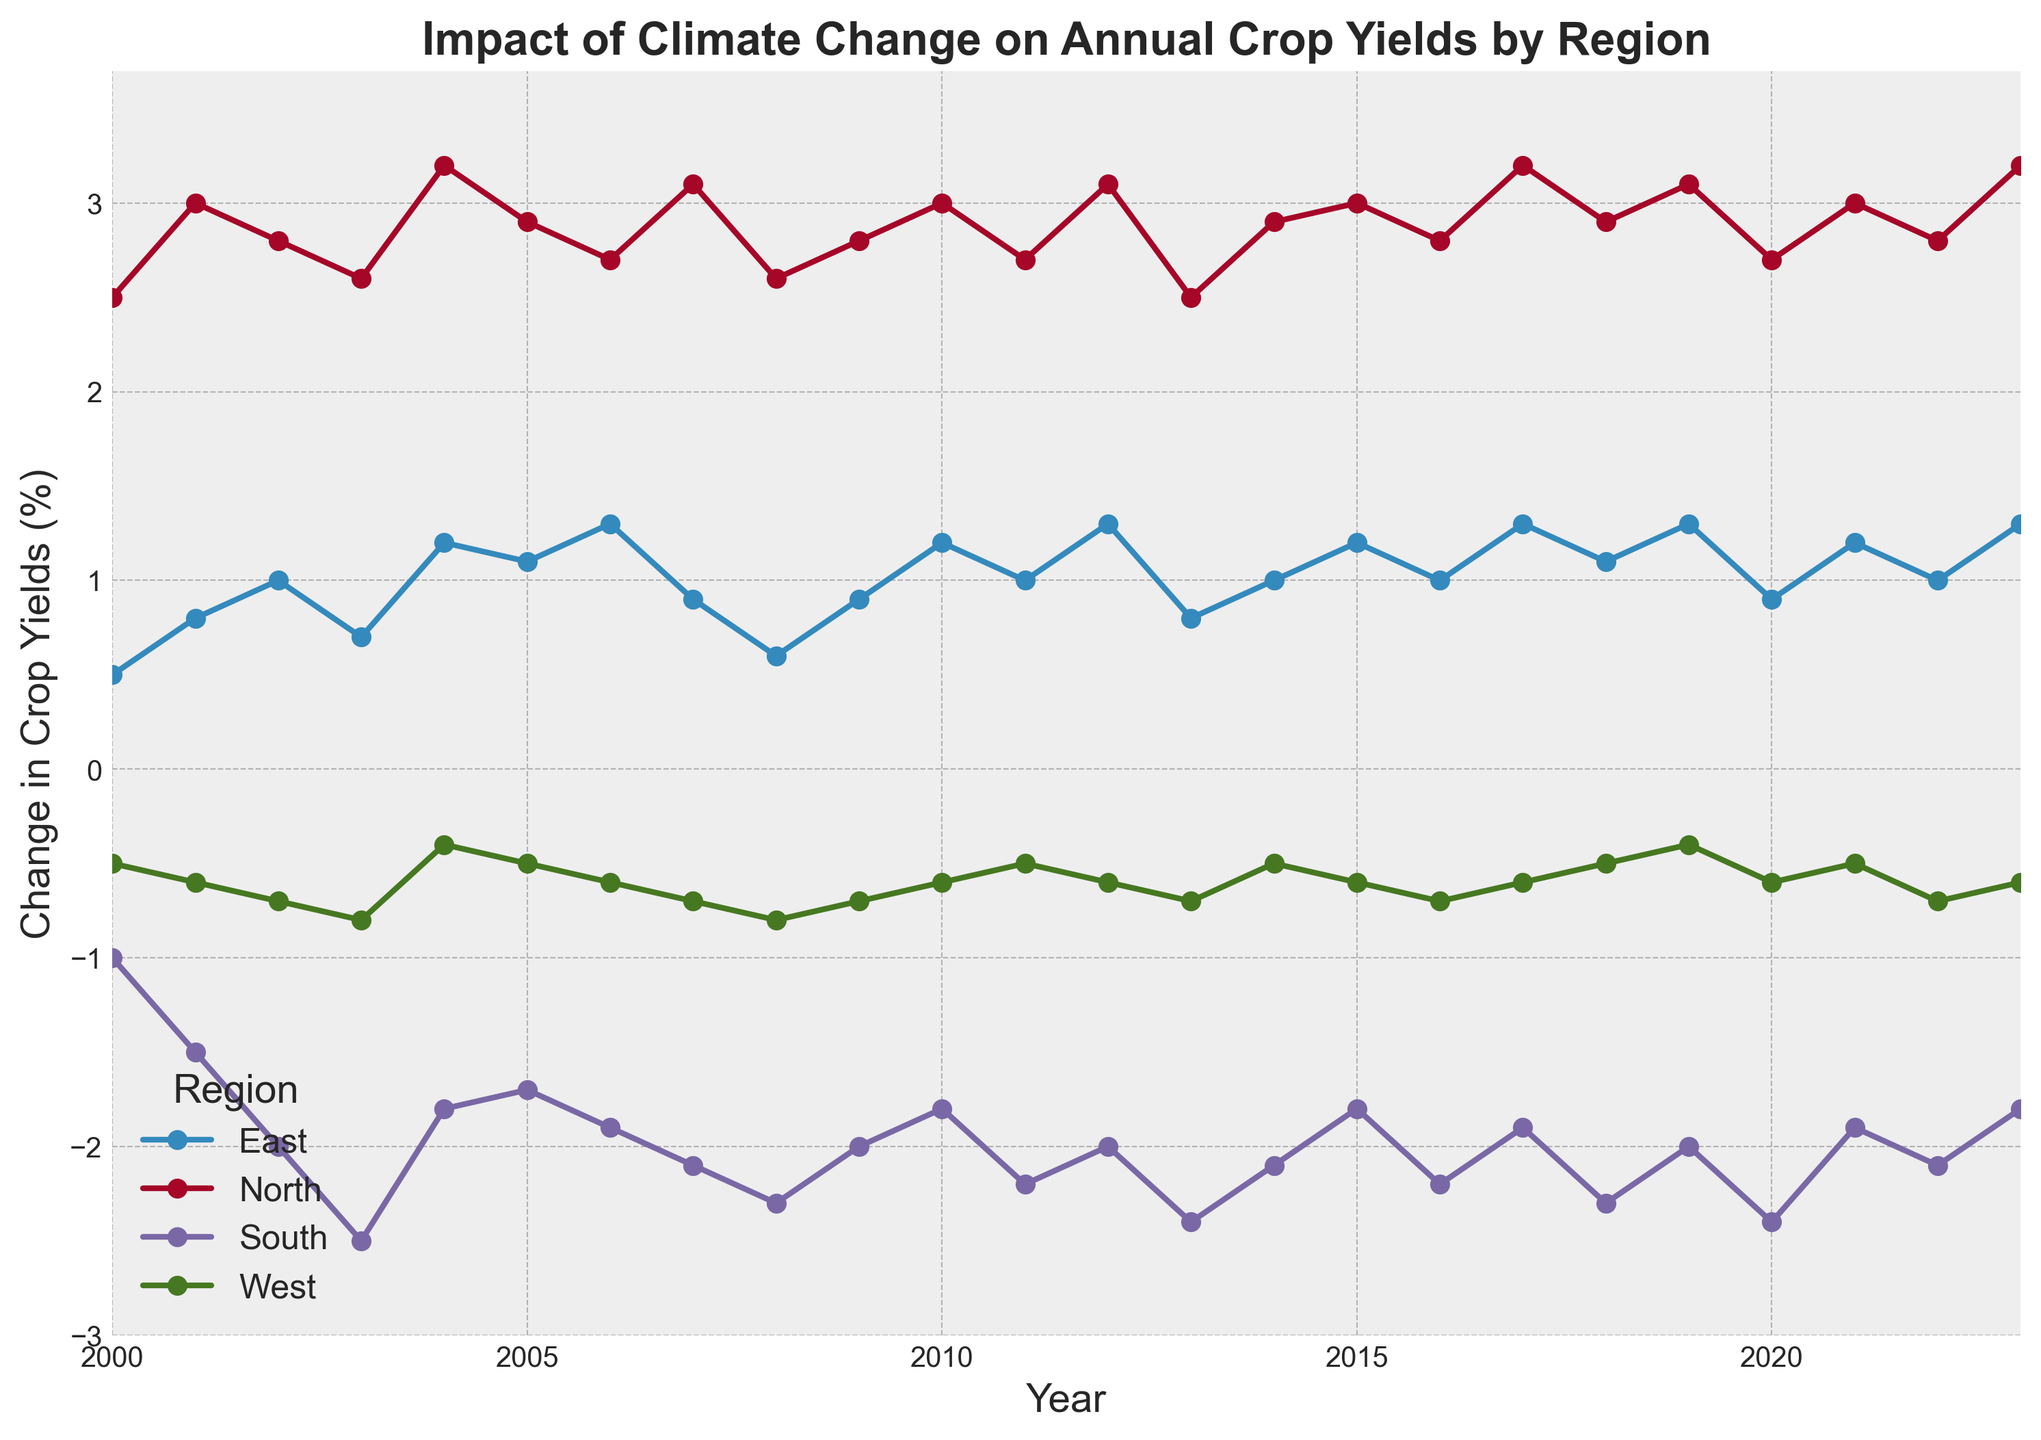Which region shows the most consistent positive change in crop yields over the years? By analyzing the lines representing each region, the North region shows a consistently positive change in crop yields each year, with values mostly increasing or staying relatively steady.
Answer: North Which year shows the highest positive change in crop yields for the North region? Observing the plot, the North region's highest point is in the year 2023, with the value peaking at 3.2%.
Answer: 2023 In which year did the South region experience the highest negative change in crop yields? By identifying the lowest point in the South region's line, the most significant negative change is observed in 2003, where the value drops to -2.5%.
Answer: 2003 Compare the crop yield changes between the East and West regions in 2015. For 2015, the East region shows a change of 1.2% while the West region shows a change of -0.6%. Hence, the East has a higher yield change than the West.
Answer: East has a higher yield change What is the average change in crop yields for the North region between 2010 and 2020? Summing the North region's values from 2010 to 2020: (3.0, 2.7, 3.1, 2.5, 2.9, 3.0, 2.8, 3.2, 2.9, 3.1, 2.7) gives 31.9. Dividing this by the number of years (11) results in an average of approximately 2.9%.
Answer: 2.9 Which year shows an identical change in crop yields for East and West regions? By looking at the points where the values for East and West intersect, in 2006, both regions have identical changes in crop yields of 1.3% for the East and -0.6% for the West.
Answer: 2006 Comparing the trendlines, did the East region show an overall increasing or decreasing trend from 2000 to 2023? Observing the general direction of the East's line, the values start at 0.5% in 2000 and reach 1.3% in 2023, indicating an overall increasing trend.
Answer: Increasing How does the variability of the South region's crop yields compare with the variability in the North region? The South's line fluctuates more dramatically with larger negative values and wider changes (from -1.0 to -2.5), while the North shows relatively steady increases (between 2.5 to 3.2). Thus, the South has more variability.
Answer: South has more variability Between which years did the West region see its steepest decline in crop yield change? The steepest decline for the West can be identified between 2000 (at -0.5) and 2008 (-0.8), showing a steady and noticeable decline over these years.
Answer: 2000-2008 